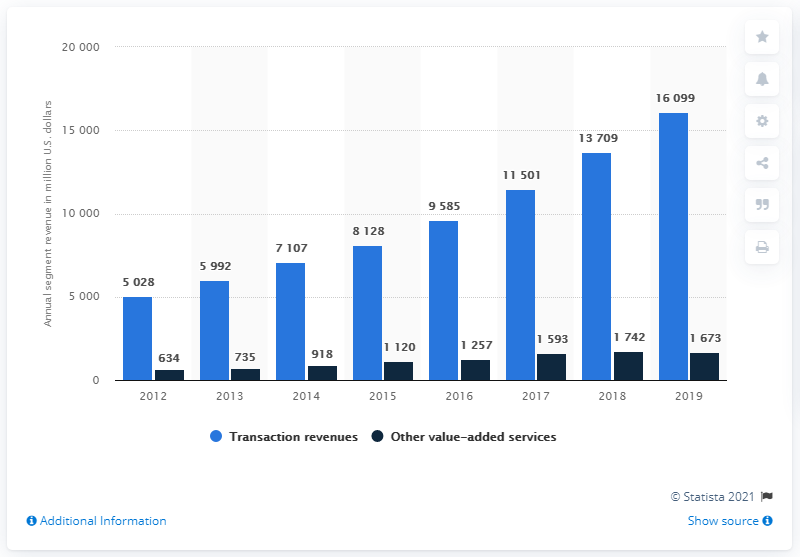Can you describe the trend in transaction revenues from 2012 to 2019? Certainly. From 2012 to 2019, the chart shows an overall increasing trend in transaction revenues. Beginning at approximately $5,028 million in 2012, there is a noticeable advancement each year, peaking at $16,099 million in 2019. This progression suggests significant growth in this revenue sector over the span of these years. 